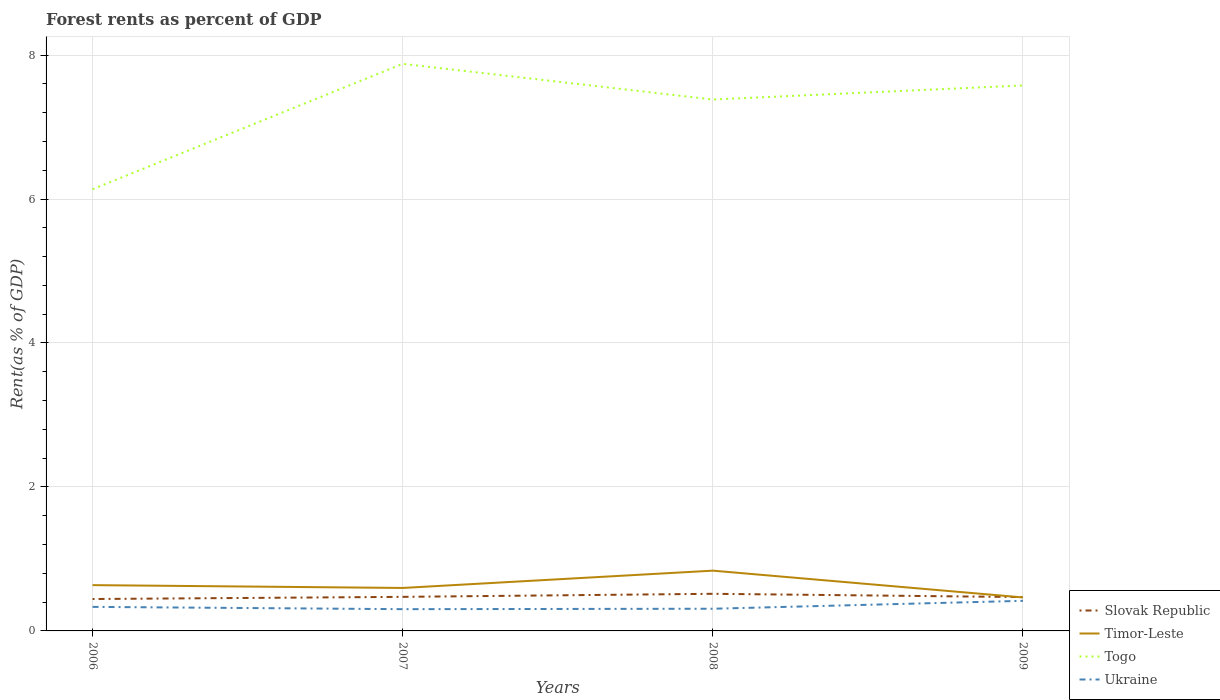How many different coloured lines are there?
Make the answer very short. 4. Does the line corresponding to Timor-Leste intersect with the line corresponding to Ukraine?
Give a very brief answer. No. Is the number of lines equal to the number of legend labels?
Make the answer very short. Yes. Across all years, what is the maximum forest rent in Togo?
Your answer should be very brief. 6.14. What is the total forest rent in Timor-Leste in the graph?
Offer a terse response. 0.04. What is the difference between the highest and the second highest forest rent in Togo?
Offer a terse response. 1.74. What is the difference between the highest and the lowest forest rent in Slovak Republic?
Give a very brief answer. 1. Is the forest rent in Slovak Republic strictly greater than the forest rent in Togo over the years?
Provide a short and direct response. Yes. How many lines are there?
Provide a succinct answer. 4. How many years are there in the graph?
Offer a very short reply. 4. Does the graph contain any zero values?
Give a very brief answer. No. Does the graph contain grids?
Keep it short and to the point. Yes. Where does the legend appear in the graph?
Provide a short and direct response. Bottom right. How many legend labels are there?
Offer a very short reply. 4. What is the title of the graph?
Your answer should be very brief. Forest rents as percent of GDP. Does "Cabo Verde" appear as one of the legend labels in the graph?
Keep it short and to the point. No. What is the label or title of the X-axis?
Offer a very short reply. Years. What is the label or title of the Y-axis?
Your answer should be compact. Rent(as % of GDP). What is the Rent(as % of GDP) of Slovak Republic in 2006?
Provide a short and direct response. 0.44. What is the Rent(as % of GDP) of Timor-Leste in 2006?
Give a very brief answer. 0.64. What is the Rent(as % of GDP) of Togo in 2006?
Offer a terse response. 6.14. What is the Rent(as % of GDP) in Ukraine in 2006?
Offer a terse response. 0.33. What is the Rent(as % of GDP) of Slovak Republic in 2007?
Give a very brief answer. 0.47. What is the Rent(as % of GDP) in Timor-Leste in 2007?
Your response must be concise. 0.6. What is the Rent(as % of GDP) in Togo in 2007?
Make the answer very short. 7.88. What is the Rent(as % of GDP) in Ukraine in 2007?
Ensure brevity in your answer.  0.3. What is the Rent(as % of GDP) of Slovak Republic in 2008?
Your response must be concise. 0.52. What is the Rent(as % of GDP) of Timor-Leste in 2008?
Make the answer very short. 0.84. What is the Rent(as % of GDP) of Togo in 2008?
Give a very brief answer. 7.38. What is the Rent(as % of GDP) in Ukraine in 2008?
Your answer should be very brief. 0.31. What is the Rent(as % of GDP) in Slovak Republic in 2009?
Offer a very short reply. 0.47. What is the Rent(as % of GDP) of Timor-Leste in 2009?
Ensure brevity in your answer.  0.47. What is the Rent(as % of GDP) in Togo in 2009?
Ensure brevity in your answer.  7.58. What is the Rent(as % of GDP) in Ukraine in 2009?
Make the answer very short. 0.42. Across all years, what is the maximum Rent(as % of GDP) in Slovak Republic?
Provide a succinct answer. 0.52. Across all years, what is the maximum Rent(as % of GDP) of Timor-Leste?
Offer a very short reply. 0.84. Across all years, what is the maximum Rent(as % of GDP) in Togo?
Offer a very short reply. 7.88. Across all years, what is the maximum Rent(as % of GDP) of Ukraine?
Your answer should be compact. 0.42. Across all years, what is the minimum Rent(as % of GDP) of Slovak Republic?
Your answer should be compact. 0.44. Across all years, what is the minimum Rent(as % of GDP) of Timor-Leste?
Keep it short and to the point. 0.47. Across all years, what is the minimum Rent(as % of GDP) of Togo?
Your response must be concise. 6.14. Across all years, what is the minimum Rent(as % of GDP) of Ukraine?
Provide a succinct answer. 0.3. What is the total Rent(as % of GDP) in Slovak Republic in the graph?
Ensure brevity in your answer.  1.9. What is the total Rent(as % of GDP) in Timor-Leste in the graph?
Your answer should be compact. 2.54. What is the total Rent(as % of GDP) of Togo in the graph?
Give a very brief answer. 28.97. What is the total Rent(as % of GDP) in Ukraine in the graph?
Offer a terse response. 1.36. What is the difference between the Rent(as % of GDP) of Slovak Republic in 2006 and that in 2007?
Provide a short and direct response. -0.03. What is the difference between the Rent(as % of GDP) of Timor-Leste in 2006 and that in 2007?
Your response must be concise. 0.04. What is the difference between the Rent(as % of GDP) in Togo in 2006 and that in 2007?
Provide a succinct answer. -1.74. What is the difference between the Rent(as % of GDP) in Ukraine in 2006 and that in 2007?
Make the answer very short. 0.03. What is the difference between the Rent(as % of GDP) in Slovak Republic in 2006 and that in 2008?
Provide a short and direct response. -0.07. What is the difference between the Rent(as % of GDP) of Timor-Leste in 2006 and that in 2008?
Provide a succinct answer. -0.2. What is the difference between the Rent(as % of GDP) in Togo in 2006 and that in 2008?
Offer a terse response. -1.25. What is the difference between the Rent(as % of GDP) of Ukraine in 2006 and that in 2008?
Keep it short and to the point. 0.03. What is the difference between the Rent(as % of GDP) of Slovak Republic in 2006 and that in 2009?
Make the answer very short. -0.03. What is the difference between the Rent(as % of GDP) of Timor-Leste in 2006 and that in 2009?
Your answer should be compact. 0.17. What is the difference between the Rent(as % of GDP) in Togo in 2006 and that in 2009?
Your answer should be very brief. -1.44. What is the difference between the Rent(as % of GDP) of Ukraine in 2006 and that in 2009?
Your answer should be very brief. -0.08. What is the difference between the Rent(as % of GDP) of Slovak Republic in 2007 and that in 2008?
Offer a terse response. -0.04. What is the difference between the Rent(as % of GDP) of Timor-Leste in 2007 and that in 2008?
Offer a very short reply. -0.24. What is the difference between the Rent(as % of GDP) of Togo in 2007 and that in 2008?
Give a very brief answer. 0.5. What is the difference between the Rent(as % of GDP) in Ukraine in 2007 and that in 2008?
Your answer should be very brief. -0.01. What is the difference between the Rent(as % of GDP) in Slovak Republic in 2007 and that in 2009?
Your answer should be very brief. 0. What is the difference between the Rent(as % of GDP) in Timor-Leste in 2007 and that in 2009?
Provide a succinct answer. 0.13. What is the difference between the Rent(as % of GDP) in Togo in 2007 and that in 2009?
Your response must be concise. 0.3. What is the difference between the Rent(as % of GDP) of Ukraine in 2007 and that in 2009?
Offer a terse response. -0.12. What is the difference between the Rent(as % of GDP) in Slovak Republic in 2008 and that in 2009?
Give a very brief answer. 0.05. What is the difference between the Rent(as % of GDP) in Timor-Leste in 2008 and that in 2009?
Provide a short and direct response. 0.37. What is the difference between the Rent(as % of GDP) of Togo in 2008 and that in 2009?
Provide a short and direct response. -0.2. What is the difference between the Rent(as % of GDP) in Ukraine in 2008 and that in 2009?
Provide a short and direct response. -0.11. What is the difference between the Rent(as % of GDP) of Slovak Republic in 2006 and the Rent(as % of GDP) of Timor-Leste in 2007?
Ensure brevity in your answer.  -0.15. What is the difference between the Rent(as % of GDP) of Slovak Republic in 2006 and the Rent(as % of GDP) of Togo in 2007?
Provide a short and direct response. -7.43. What is the difference between the Rent(as % of GDP) in Slovak Republic in 2006 and the Rent(as % of GDP) in Ukraine in 2007?
Ensure brevity in your answer.  0.14. What is the difference between the Rent(as % of GDP) of Timor-Leste in 2006 and the Rent(as % of GDP) of Togo in 2007?
Give a very brief answer. -7.24. What is the difference between the Rent(as % of GDP) in Timor-Leste in 2006 and the Rent(as % of GDP) in Ukraine in 2007?
Ensure brevity in your answer.  0.33. What is the difference between the Rent(as % of GDP) in Togo in 2006 and the Rent(as % of GDP) in Ukraine in 2007?
Give a very brief answer. 5.83. What is the difference between the Rent(as % of GDP) in Slovak Republic in 2006 and the Rent(as % of GDP) in Timor-Leste in 2008?
Offer a terse response. -0.39. What is the difference between the Rent(as % of GDP) of Slovak Republic in 2006 and the Rent(as % of GDP) of Togo in 2008?
Your answer should be very brief. -6.94. What is the difference between the Rent(as % of GDP) of Slovak Republic in 2006 and the Rent(as % of GDP) of Ukraine in 2008?
Your answer should be very brief. 0.14. What is the difference between the Rent(as % of GDP) of Timor-Leste in 2006 and the Rent(as % of GDP) of Togo in 2008?
Your response must be concise. -6.75. What is the difference between the Rent(as % of GDP) of Timor-Leste in 2006 and the Rent(as % of GDP) of Ukraine in 2008?
Your answer should be compact. 0.33. What is the difference between the Rent(as % of GDP) of Togo in 2006 and the Rent(as % of GDP) of Ukraine in 2008?
Provide a short and direct response. 5.83. What is the difference between the Rent(as % of GDP) of Slovak Republic in 2006 and the Rent(as % of GDP) of Timor-Leste in 2009?
Your answer should be very brief. -0.02. What is the difference between the Rent(as % of GDP) of Slovak Republic in 2006 and the Rent(as % of GDP) of Togo in 2009?
Give a very brief answer. -7.13. What is the difference between the Rent(as % of GDP) of Slovak Republic in 2006 and the Rent(as % of GDP) of Ukraine in 2009?
Provide a short and direct response. 0.03. What is the difference between the Rent(as % of GDP) in Timor-Leste in 2006 and the Rent(as % of GDP) in Togo in 2009?
Keep it short and to the point. -6.94. What is the difference between the Rent(as % of GDP) in Timor-Leste in 2006 and the Rent(as % of GDP) in Ukraine in 2009?
Offer a very short reply. 0.22. What is the difference between the Rent(as % of GDP) of Togo in 2006 and the Rent(as % of GDP) of Ukraine in 2009?
Your response must be concise. 5.72. What is the difference between the Rent(as % of GDP) of Slovak Republic in 2007 and the Rent(as % of GDP) of Timor-Leste in 2008?
Ensure brevity in your answer.  -0.36. What is the difference between the Rent(as % of GDP) in Slovak Republic in 2007 and the Rent(as % of GDP) in Togo in 2008?
Provide a short and direct response. -6.91. What is the difference between the Rent(as % of GDP) of Slovak Republic in 2007 and the Rent(as % of GDP) of Ukraine in 2008?
Provide a short and direct response. 0.17. What is the difference between the Rent(as % of GDP) of Timor-Leste in 2007 and the Rent(as % of GDP) of Togo in 2008?
Your answer should be compact. -6.79. What is the difference between the Rent(as % of GDP) in Timor-Leste in 2007 and the Rent(as % of GDP) in Ukraine in 2008?
Make the answer very short. 0.29. What is the difference between the Rent(as % of GDP) of Togo in 2007 and the Rent(as % of GDP) of Ukraine in 2008?
Your response must be concise. 7.57. What is the difference between the Rent(as % of GDP) in Slovak Republic in 2007 and the Rent(as % of GDP) in Timor-Leste in 2009?
Provide a succinct answer. 0.01. What is the difference between the Rent(as % of GDP) in Slovak Republic in 2007 and the Rent(as % of GDP) in Togo in 2009?
Offer a very short reply. -7.1. What is the difference between the Rent(as % of GDP) in Slovak Republic in 2007 and the Rent(as % of GDP) in Ukraine in 2009?
Your answer should be compact. 0.06. What is the difference between the Rent(as % of GDP) of Timor-Leste in 2007 and the Rent(as % of GDP) of Togo in 2009?
Give a very brief answer. -6.98. What is the difference between the Rent(as % of GDP) in Timor-Leste in 2007 and the Rent(as % of GDP) in Ukraine in 2009?
Offer a terse response. 0.18. What is the difference between the Rent(as % of GDP) in Togo in 2007 and the Rent(as % of GDP) in Ukraine in 2009?
Make the answer very short. 7.46. What is the difference between the Rent(as % of GDP) in Slovak Republic in 2008 and the Rent(as % of GDP) in Timor-Leste in 2009?
Provide a short and direct response. 0.05. What is the difference between the Rent(as % of GDP) in Slovak Republic in 2008 and the Rent(as % of GDP) in Togo in 2009?
Your response must be concise. -7.06. What is the difference between the Rent(as % of GDP) of Slovak Republic in 2008 and the Rent(as % of GDP) of Ukraine in 2009?
Keep it short and to the point. 0.1. What is the difference between the Rent(as % of GDP) in Timor-Leste in 2008 and the Rent(as % of GDP) in Togo in 2009?
Your answer should be compact. -6.74. What is the difference between the Rent(as % of GDP) of Timor-Leste in 2008 and the Rent(as % of GDP) of Ukraine in 2009?
Your response must be concise. 0.42. What is the difference between the Rent(as % of GDP) of Togo in 2008 and the Rent(as % of GDP) of Ukraine in 2009?
Your answer should be very brief. 6.96. What is the average Rent(as % of GDP) in Slovak Republic per year?
Make the answer very short. 0.48. What is the average Rent(as % of GDP) of Timor-Leste per year?
Offer a very short reply. 0.63. What is the average Rent(as % of GDP) of Togo per year?
Provide a short and direct response. 7.24. What is the average Rent(as % of GDP) in Ukraine per year?
Give a very brief answer. 0.34. In the year 2006, what is the difference between the Rent(as % of GDP) in Slovak Republic and Rent(as % of GDP) in Timor-Leste?
Provide a short and direct response. -0.19. In the year 2006, what is the difference between the Rent(as % of GDP) of Slovak Republic and Rent(as % of GDP) of Togo?
Your answer should be very brief. -5.69. In the year 2006, what is the difference between the Rent(as % of GDP) in Slovak Republic and Rent(as % of GDP) in Ukraine?
Give a very brief answer. 0.11. In the year 2006, what is the difference between the Rent(as % of GDP) of Timor-Leste and Rent(as % of GDP) of Ukraine?
Your answer should be compact. 0.3. In the year 2006, what is the difference between the Rent(as % of GDP) of Togo and Rent(as % of GDP) of Ukraine?
Ensure brevity in your answer.  5.8. In the year 2007, what is the difference between the Rent(as % of GDP) of Slovak Republic and Rent(as % of GDP) of Timor-Leste?
Your answer should be compact. -0.12. In the year 2007, what is the difference between the Rent(as % of GDP) of Slovak Republic and Rent(as % of GDP) of Togo?
Your answer should be compact. -7.4. In the year 2007, what is the difference between the Rent(as % of GDP) in Slovak Republic and Rent(as % of GDP) in Ukraine?
Ensure brevity in your answer.  0.17. In the year 2007, what is the difference between the Rent(as % of GDP) in Timor-Leste and Rent(as % of GDP) in Togo?
Give a very brief answer. -7.28. In the year 2007, what is the difference between the Rent(as % of GDP) in Timor-Leste and Rent(as % of GDP) in Ukraine?
Ensure brevity in your answer.  0.29. In the year 2007, what is the difference between the Rent(as % of GDP) of Togo and Rent(as % of GDP) of Ukraine?
Ensure brevity in your answer.  7.58. In the year 2008, what is the difference between the Rent(as % of GDP) of Slovak Republic and Rent(as % of GDP) of Timor-Leste?
Your answer should be very brief. -0.32. In the year 2008, what is the difference between the Rent(as % of GDP) of Slovak Republic and Rent(as % of GDP) of Togo?
Give a very brief answer. -6.87. In the year 2008, what is the difference between the Rent(as % of GDP) in Slovak Republic and Rent(as % of GDP) in Ukraine?
Provide a short and direct response. 0.21. In the year 2008, what is the difference between the Rent(as % of GDP) in Timor-Leste and Rent(as % of GDP) in Togo?
Keep it short and to the point. -6.55. In the year 2008, what is the difference between the Rent(as % of GDP) in Timor-Leste and Rent(as % of GDP) in Ukraine?
Keep it short and to the point. 0.53. In the year 2008, what is the difference between the Rent(as % of GDP) in Togo and Rent(as % of GDP) in Ukraine?
Offer a very short reply. 7.07. In the year 2009, what is the difference between the Rent(as % of GDP) in Slovak Republic and Rent(as % of GDP) in Timor-Leste?
Your answer should be very brief. 0. In the year 2009, what is the difference between the Rent(as % of GDP) of Slovak Republic and Rent(as % of GDP) of Togo?
Ensure brevity in your answer.  -7.11. In the year 2009, what is the difference between the Rent(as % of GDP) in Slovak Republic and Rent(as % of GDP) in Ukraine?
Your answer should be compact. 0.05. In the year 2009, what is the difference between the Rent(as % of GDP) of Timor-Leste and Rent(as % of GDP) of Togo?
Your answer should be very brief. -7.11. In the year 2009, what is the difference between the Rent(as % of GDP) in Timor-Leste and Rent(as % of GDP) in Ukraine?
Give a very brief answer. 0.05. In the year 2009, what is the difference between the Rent(as % of GDP) of Togo and Rent(as % of GDP) of Ukraine?
Provide a succinct answer. 7.16. What is the ratio of the Rent(as % of GDP) in Slovak Republic in 2006 to that in 2007?
Provide a succinct answer. 0.94. What is the ratio of the Rent(as % of GDP) in Timor-Leste in 2006 to that in 2007?
Make the answer very short. 1.07. What is the ratio of the Rent(as % of GDP) of Togo in 2006 to that in 2007?
Offer a terse response. 0.78. What is the ratio of the Rent(as % of GDP) in Ukraine in 2006 to that in 2007?
Keep it short and to the point. 1.11. What is the ratio of the Rent(as % of GDP) in Slovak Republic in 2006 to that in 2008?
Your response must be concise. 0.86. What is the ratio of the Rent(as % of GDP) of Timor-Leste in 2006 to that in 2008?
Keep it short and to the point. 0.76. What is the ratio of the Rent(as % of GDP) in Togo in 2006 to that in 2008?
Provide a succinct answer. 0.83. What is the ratio of the Rent(as % of GDP) in Ukraine in 2006 to that in 2008?
Ensure brevity in your answer.  1.08. What is the ratio of the Rent(as % of GDP) of Slovak Republic in 2006 to that in 2009?
Offer a terse response. 0.94. What is the ratio of the Rent(as % of GDP) in Timor-Leste in 2006 to that in 2009?
Make the answer very short. 1.37. What is the ratio of the Rent(as % of GDP) in Togo in 2006 to that in 2009?
Your response must be concise. 0.81. What is the ratio of the Rent(as % of GDP) in Ukraine in 2006 to that in 2009?
Ensure brevity in your answer.  0.8. What is the ratio of the Rent(as % of GDP) of Slovak Republic in 2007 to that in 2008?
Provide a short and direct response. 0.92. What is the ratio of the Rent(as % of GDP) in Timor-Leste in 2007 to that in 2008?
Your answer should be very brief. 0.71. What is the ratio of the Rent(as % of GDP) in Togo in 2007 to that in 2008?
Offer a very short reply. 1.07. What is the ratio of the Rent(as % of GDP) of Ukraine in 2007 to that in 2008?
Give a very brief answer. 0.98. What is the ratio of the Rent(as % of GDP) of Slovak Republic in 2007 to that in 2009?
Your answer should be compact. 1.01. What is the ratio of the Rent(as % of GDP) in Timor-Leste in 2007 to that in 2009?
Give a very brief answer. 1.28. What is the ratio of the Rent(as % of GDP) in Togo in 2007 to that in 2009?
Make the answer very short. 1.04. What is the ratio of the Rent(as % of GDP) of Ukraine in 2007 to that in 2009?
Your answer should be very brief. 0.72. What is the ratio of the Rent(as % of GDP) in Slovak Republic in 2008 to that in 2009?
Keep it short and to the point. 1.1. What is the ratio of the Rent(as % of GDP) of Timor-Leste in 2008 to that in 2009?
Provide a succinct answer. 1.8. What is the ratio of the Rent(as % of GDP) in Togo in 2008 to that in 2009?
Offer a very short reply. 0.97. What is the ratio of the Rent(as % of GDP) of Ukraine in 2008 to that in 2009?
Offer a terse response. 0.74. What is the difference between the highest and the second highest Rent(as % of GDP) in Slovak Republic?
Ensure brevity in your answer.  0.04. What is the difference between the highest and the second highest Rent(as % of GDP) of Timor-Leste?
Keep it short and to the point. 0.2. What is the difference between the highest and the second highest Rent(as % of GDP) in Togo?
Offer a very short reply. 0.3. What is the difference between the highest and the second highest Rent(as % of GDP) in Ukraine?
Offer a terse response. 0.08. What is the difference between the highest and the lowest Rent(as % of GDP) of Slovak Republic?
Your answer should be very brief. 0.07. What is the difference between the highest and the lowest Rent(as % of GDP) in Timor-Leste?
Offer a terse response. 0.37. What is the difference between the highest and the lowest Rent(as % of GDP) in Togo?
Provide a succinct answer. 1.74. What is the difference between the highest and the lowest Rent(as % of GDP) in Ukraine?
Keep it short and to the point. 0.12. 